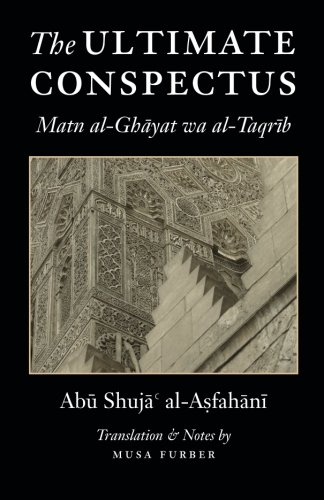Who wrote this book? The book 'The Ultimate Conspectus: Matn al-Ghayat wa al-Taqrib' was authored by Abu Shuja' al-Asfahani, a noted scholar in Islamic jurisprudence. 